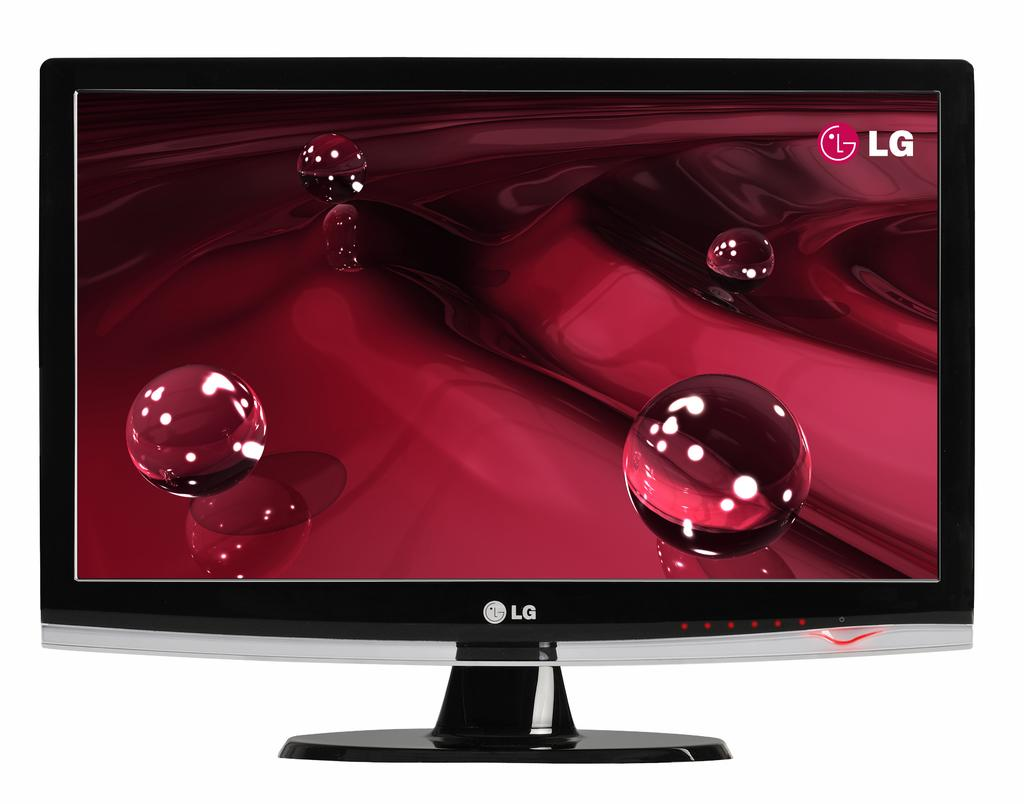Provide a one-sentence caption for the provided image. LG monitor on the bottom front of the computer. 